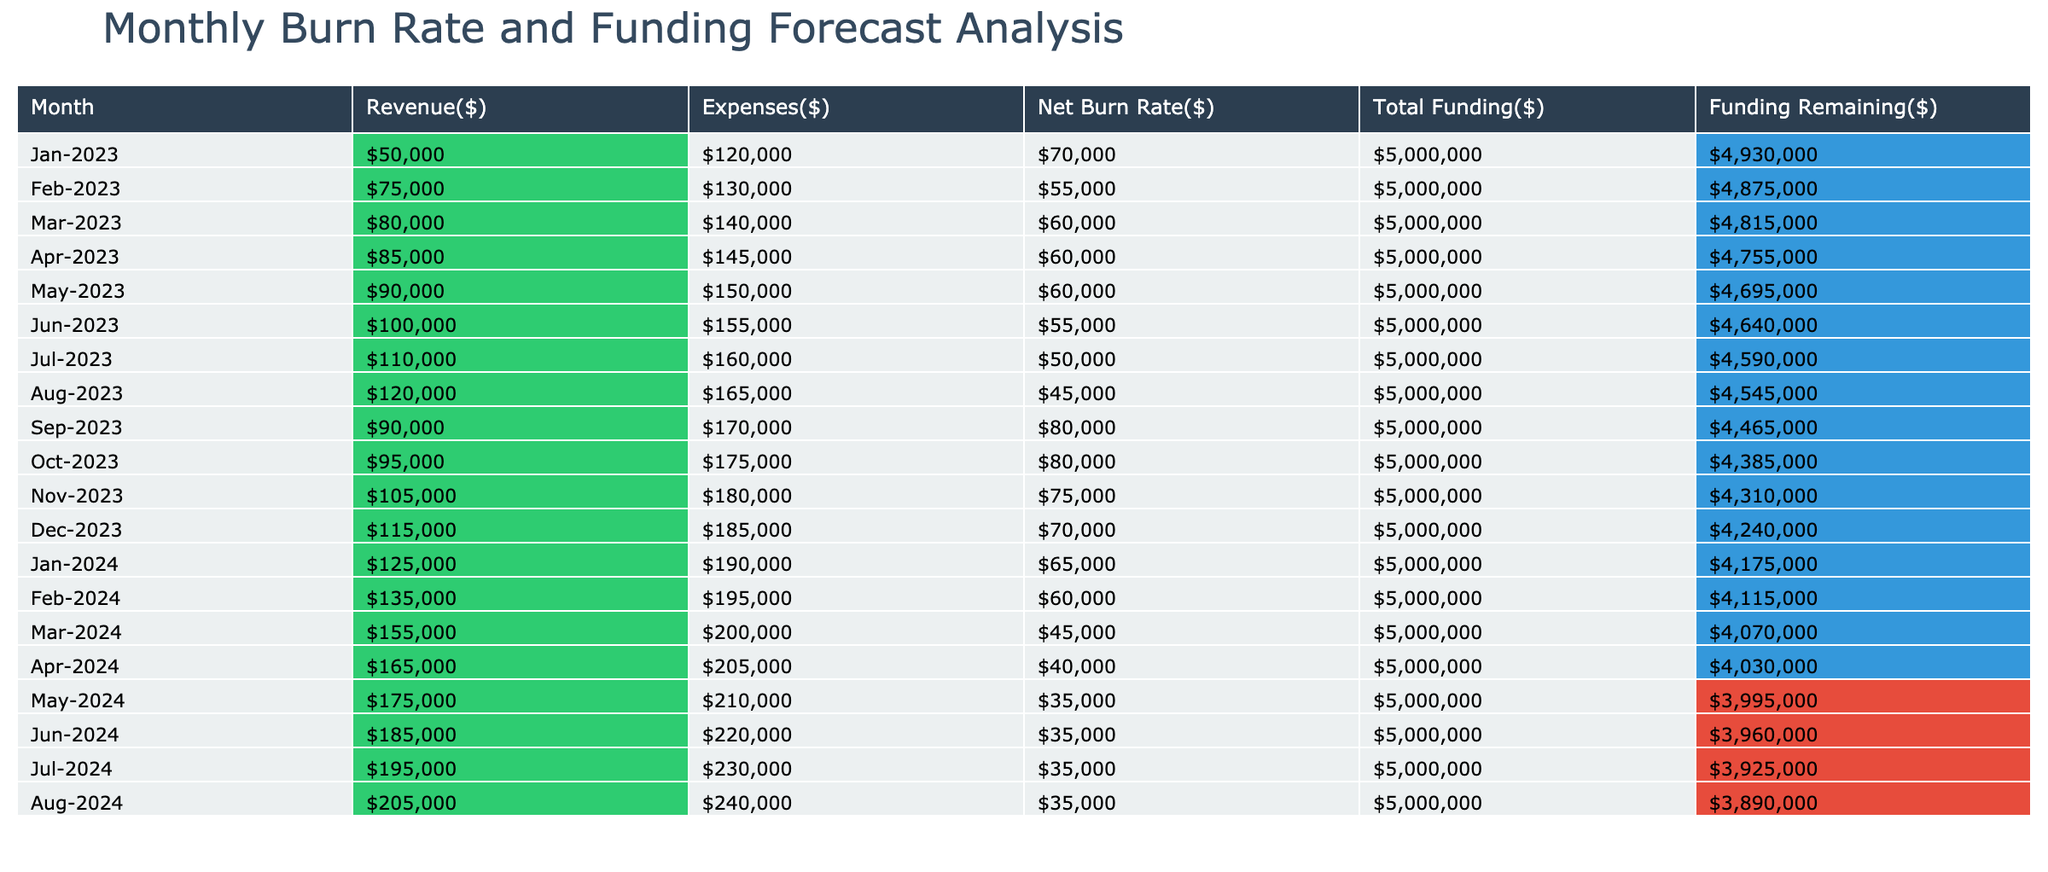What was the total revenue in October 2023? By referencing the table, the revenue for October 2023 is directly listed as $95,000.
Answer: $95,000 In which month did the expenses first exceed $180,000? Looking through the table, expenses exceeded $180,000 starting in November 2023, where the expenses are noted as $180,000.
Answer: November 2023 What is the average net burn rate from January 2023 to December 2023? To find the average net burn rate, sum the net burn rates from January to December and divide by the number of months (12). The sum is $70,000 + $55,000 + $60,000 + $60,000 + $60,000 + $55,000 + $50,000 + $45,000 + $80,000 + $80,000 + $75,000 + $70,000 = $ 675,000. Then, $675,000 / 12 = $56,250.
Answer: $56,250 Did the funding remaining decrease below $4,500,000 in 2023? Observing the data, throughout all the months listed from January to December 2023, the funding remaining never dropped below $4,500,000. The lowest recorded is $4,240,000 in December 2023, confirming that it did indeed drop below $4,500,000.
Answer: Yes What month experienced the maximum net burn rate? Analyzing the net burn rates, January 2023 shows the highest value at $70,000, which is greater than all subsequent months, confirming it as the maximum net burn rate for the available months.
Answer: January 2023 How much lower were the expenses in March 2024 compared to February 2024? The expenses in March 2024 are $200,000 while in February 2024 they are $195,000. The difference calculated is $200,000 - $195,000 = $5,000, meaning March's expenses are $5,000 higher.
Answer: $5,000 Which month had the highest funding remaining? Checking the table, January 2023 shows the highest funding remaining at $4,930,000 compared to all other months which displayed lower remaining values.
Answer: January 2023 What is the total funding remaining at the end of July 2024? From the table, the funding remaining at the end of July 2024 is $3,925,000, which can be read directly from that month's row in the table.
Answer: $3,925,000 